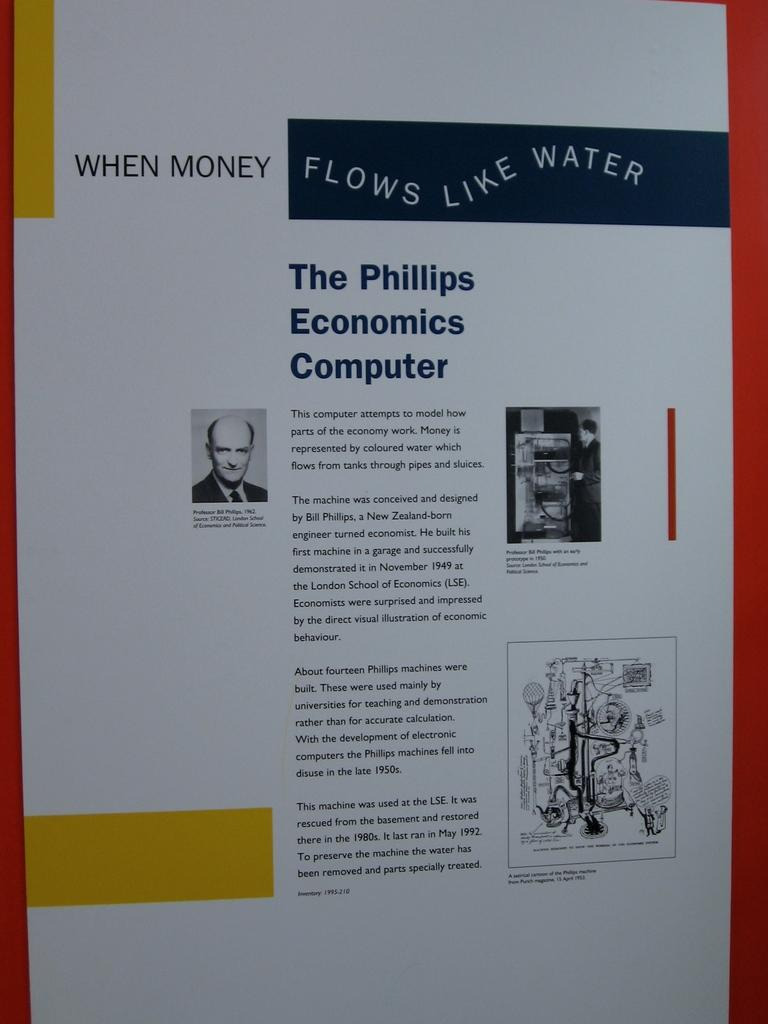<image>
Describe the image concisely. An article about The Phillips Economic Computer with explanations of what the computer does. 